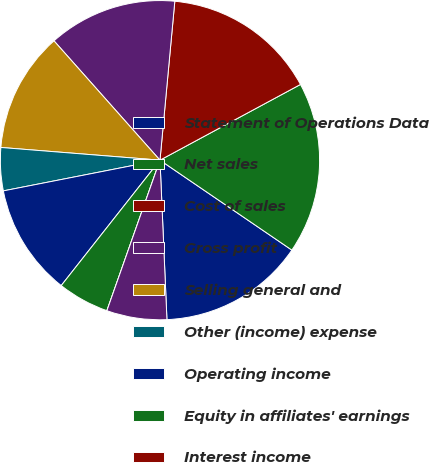<chart> <loc_0><loc_0><loc_500><loc_500><pie_chart><fcel>Statement of Operations Data<fcel>Net sales<fcel>Cost of sales<fcel>Gross profit<fcel>Selling general and<fcel>Other (income) expense<fcel>Operating income<fcel>Equity in affiliates' earnings<fcel>Interest income<fcel>Interest expense and finance<nl><fcel>14.78%<fcel>17.39%<fcel>15.65%<fcel>13.04%<fcel>12.17%<fcel>4.35%<fcel>11.3%<fcel>5.22%<fcel>0.0%<fcel>6.09%<nl></chart> 